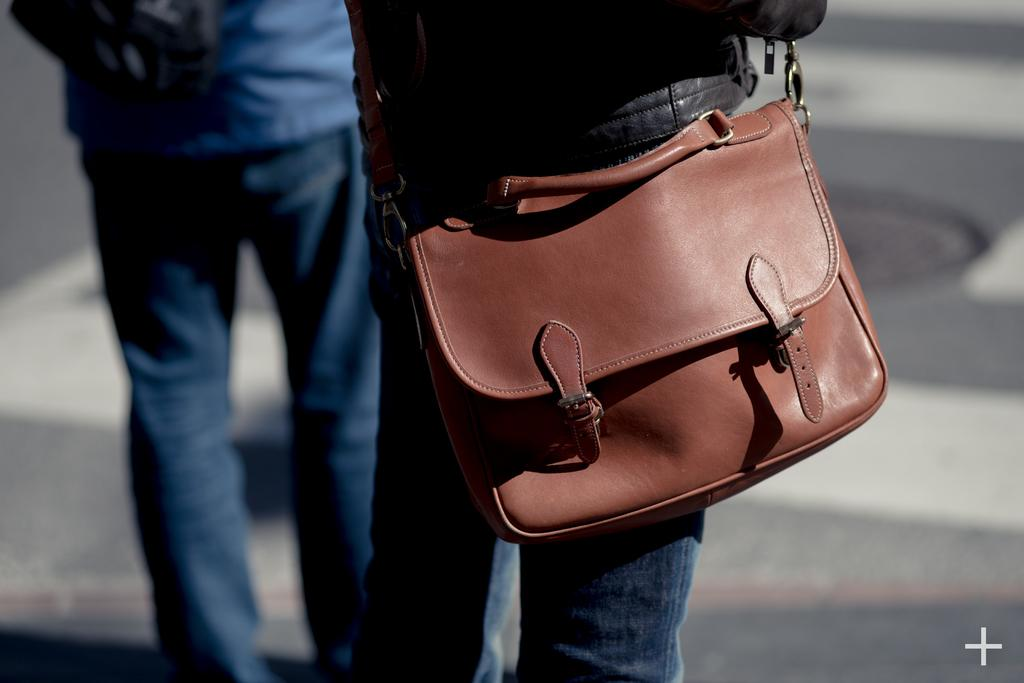How many people are in the image? There are two persons in the image. What are the people in the image doing? Both persons are standing. Can you describe any accessories or items one of the persons is carrying? One person is wearing a backpack. What type of button can be seen on the person's shirt in the image? There is no button visible on the person's shirt in the image. What kind of support is the person leaning on in the image? There is no support visible in the image, as both persons are standing without any assistance. 